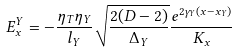<formula> <loc_0><loc_0><loc_500><loc_500>E ^ { Y } _ { x } = - \frac { \eta _ { T } \eta _ { Y } } { l _ { Y } } \sqrt { \frac { 2 ( D - 2 ) } { \Delta _ { Y } } } \frac { e ^ { 2 \gamma _ { Y } ( x - x _ { Y } ) } } { K _ { x } }</formula> 